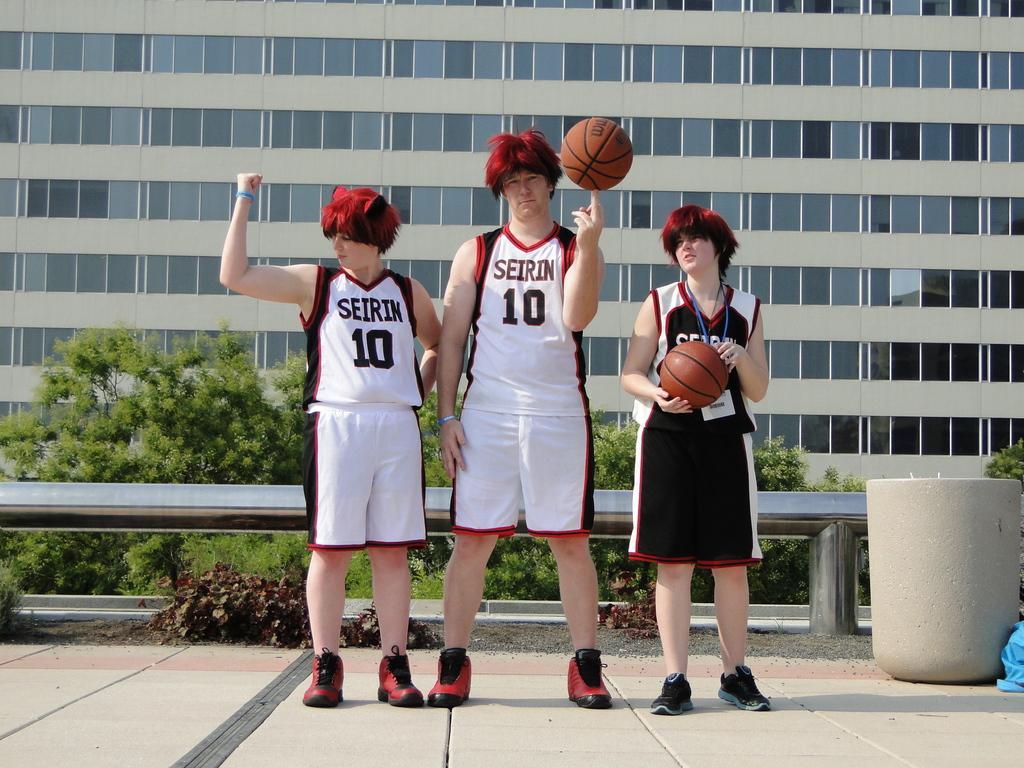What jersey number is the player on the far left wearing?
Ensure brevity in your answer.  10. 